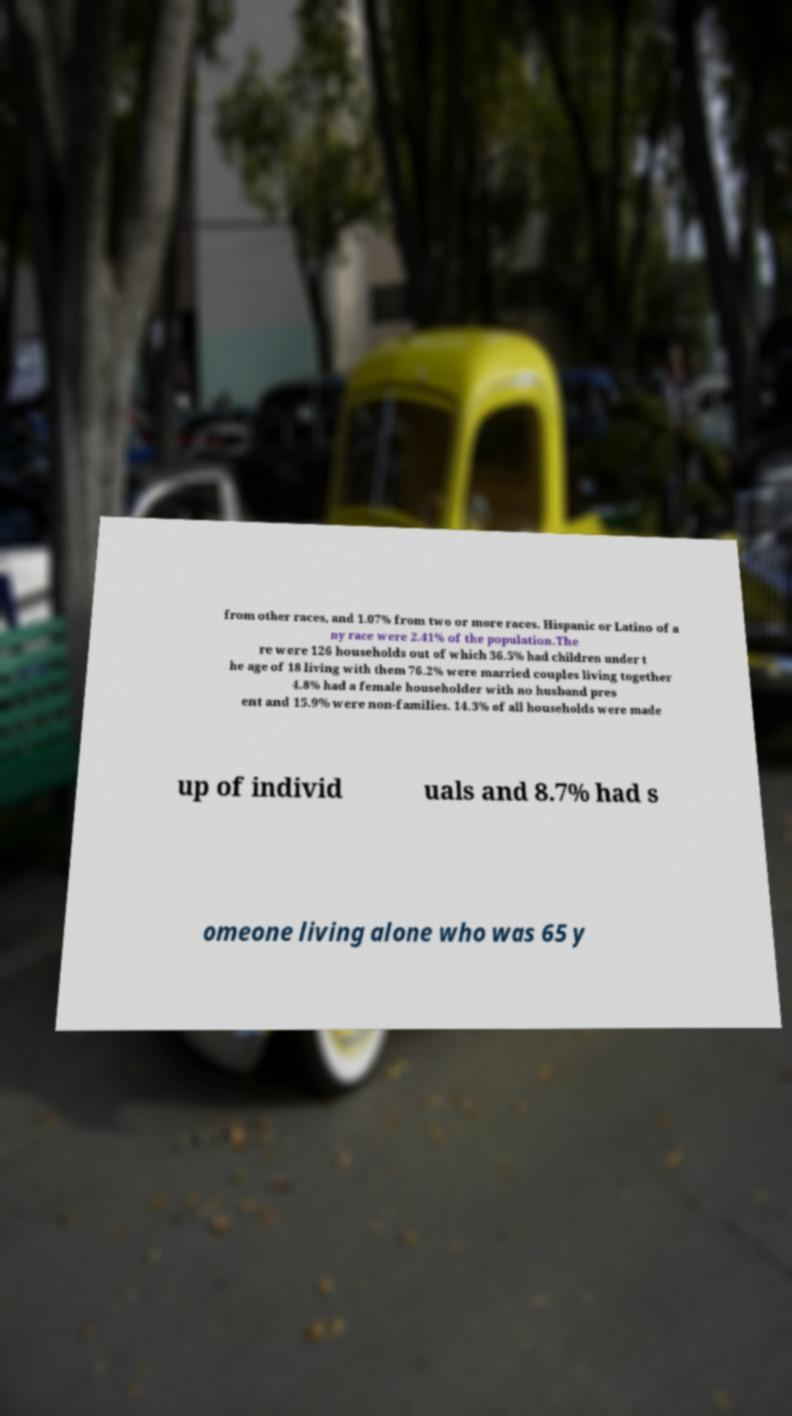Could you assist in decoding the text presented in this image and type it out clearly? from other races, and 1.07% from two or more races. Hispanic or Latino of a ny race were 2.41% of the population.The re were 126 households out of which 36.5% had children under t he age of 18 living with them 76.2% were married couples living together 4.8% had a female householder with no husband pres ent and 15.9% were non-families. 14.3% of all households were made up of individ uals and 8.7% had s omeone living alone who was 65 y 